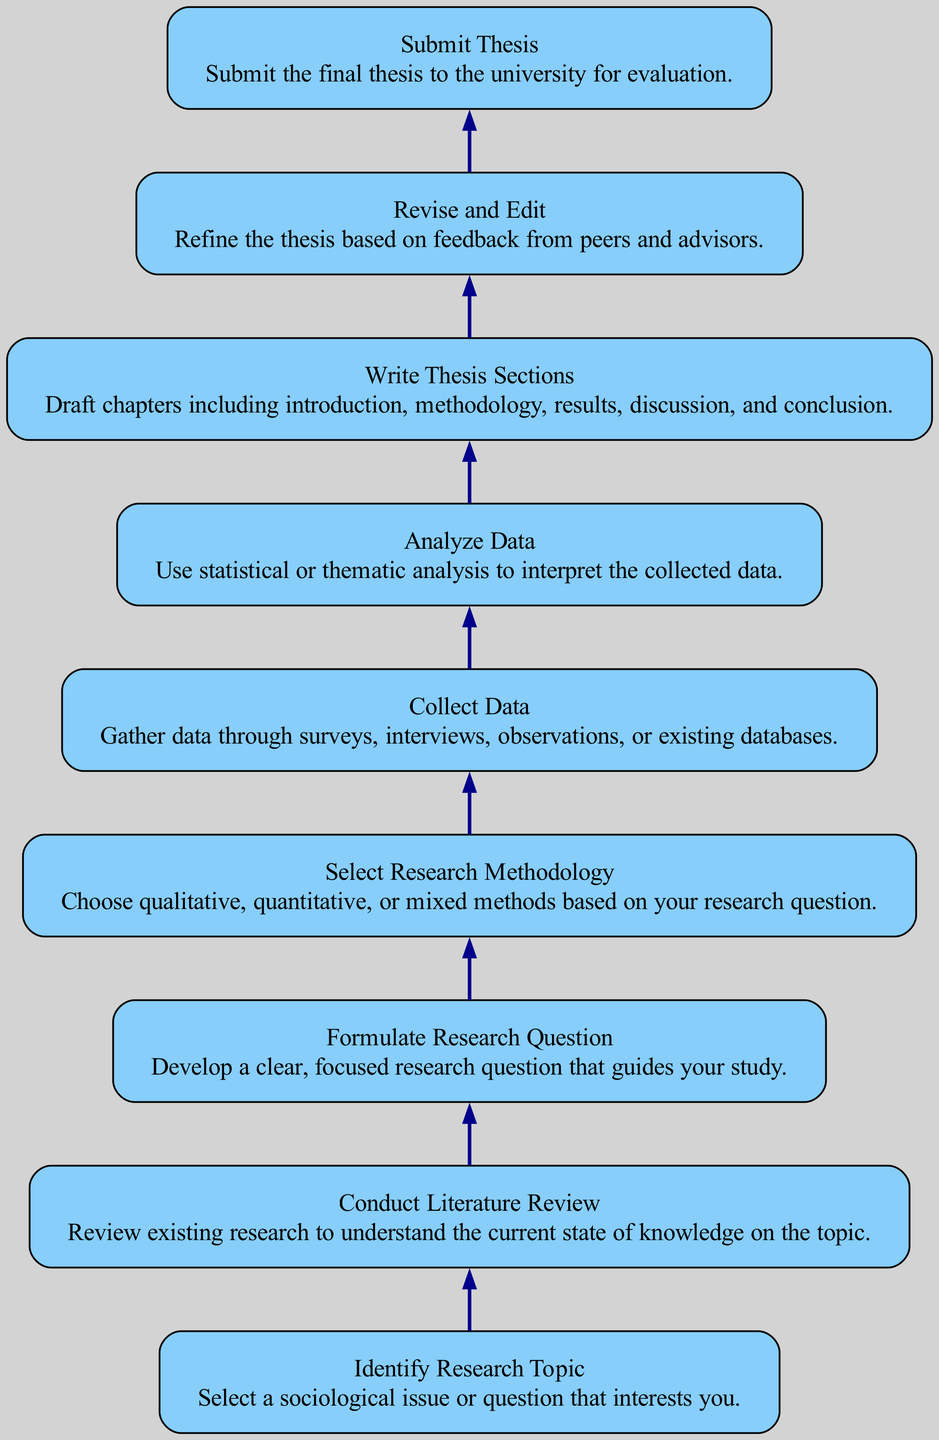What is the first step in the research project workflow? The diagram indicates that the first step in the workflow is "Identify Research Topic." This is the first node in the flow chart, leading to the subsequent step.
Answer: Identify Research Topic How many total nodes are in the diagram? To find the total nodes, we can count all the unique steps represented in the diagram. There are nine different nodes listed: topic selection, literature review, research question, methodology, data collection, data analysis, writing sections, revision, and submission.
Answer: Nine What comes after "Collect Data" in the workflow? The flow chart shows that "Analyze Data" directly follows "Collect Data." This is indicated by the directed edge connecting the two nodes in the diagram.
Answer: Analyze Data What is the last step in the research project workflow? The last step in the diagram is "Submit Thesis." This is determined by examining the final node in the flow chart, which represents the conclusion of the workflow.
Answer: Submit Thesis Which two steps are directly connected to "Revise and Edit"? The diagram displays "Write Thesis Sections" leading directly to "Revise and Edit," and "Revise and Edit" is then connected to "Submit Thesis." Thus, the two directly connected steps are "Write Thesis Sections" and "Submit Thesis."
Answer: Write Thesis Sections, Submit Thesis What type of analysis is conducted after data collection? Following "Collect Data," the next node is "Analyze Data," which indicates that data analysis takes place after data collection.
Answer: Analyze Data Which step precedes "Select Research Methodology"? The nodal flow indicates that "Formulate Research Question" directs to "Select Research Methodology," establishing that the preceding step is the formulation of the research question.
Answer: Formulate Research Question How does the flow of the diagram progress from "Literature Review"? The diagram illustrates that after "Conduct Literature Review," the workflow moves forward to "Formulate Research Question," indicating a sequential order. Thus, the flow progresses to this next step.
Answer: Formulate Research Question 